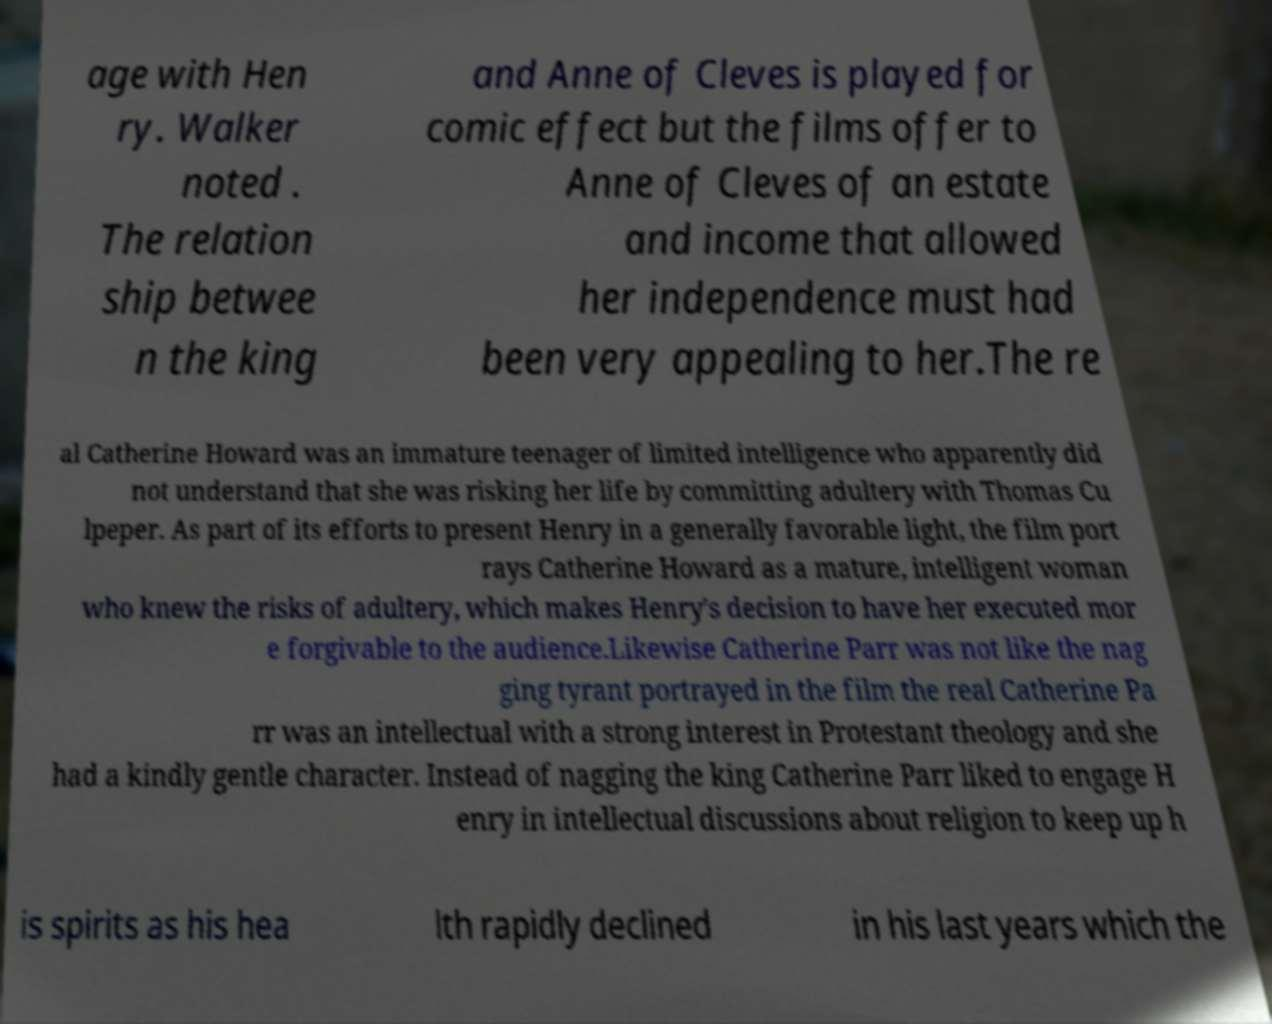Please read and relay the text visible in this image. What does it say? age with Hen ry. Walker noted . The relation ship betwee n the king and Anne of Cleves is played for comic effect but the films offer to Anne of Cleves of an estate and income that allowed her independence must had been very appealing to her.The re al Catherine Howard was an immature teenager of limited intelligence who apparently did not understand that she was risking her life by committing adultery with Thomas Cu lpeper. As part of its efforts to present Henry in a generally favorable light, the film port rays Catherine Howard as a mature, intelligent woman who knew the risks of adultery, which makes Henry's decision to have her executed mor e forgivable to the audience.Likewise Catherine Parr was not like the nag ging tyrant portrayed in the film the real Catherine Pa rr was an intellectual with a strong interest in Protestant theology and she had a kindly gentle character. Instead of nagging the king Catherine Parr liked to engage H enry in intellectual discussions about religion to keep up h is spirits as his hea lth rapidly declined in his last years which the 